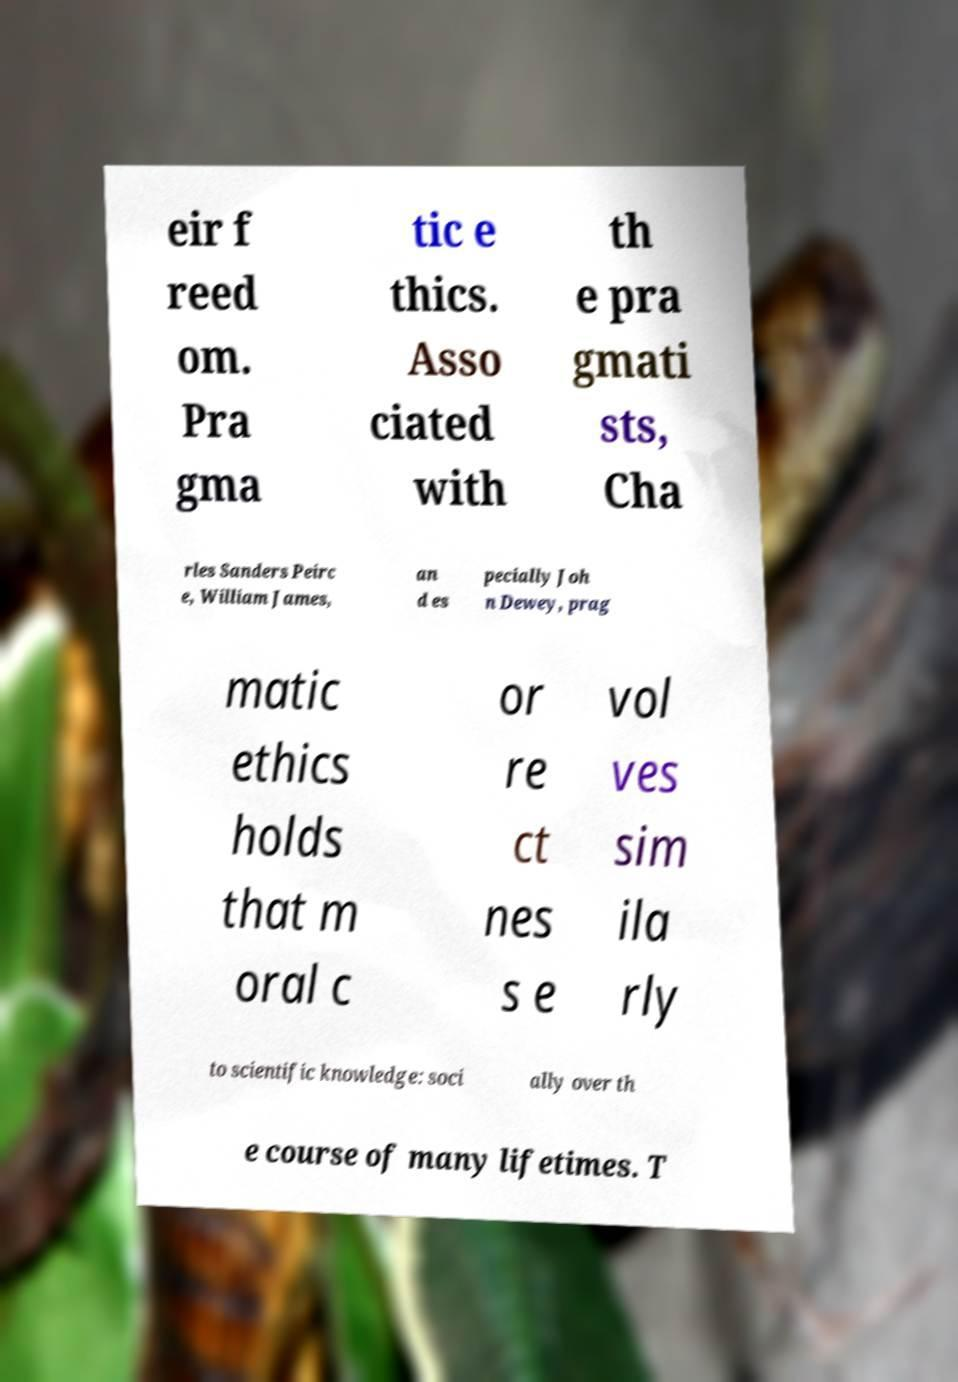There's text embedded in this image that I need extracted. Can you transcribe it verbatim? eir f reed om. Pra gma tic e thics. Asso ciated with th e pra gmati sts, Cha rles Sanders Peirc e, William James, an d es pecially Joh n Dewey, prag matic ethics holds that m oral c or re ct nes s e vol ves sim ila rly to scientific knowledge: soci ally over th e course of many lifetimes. T 